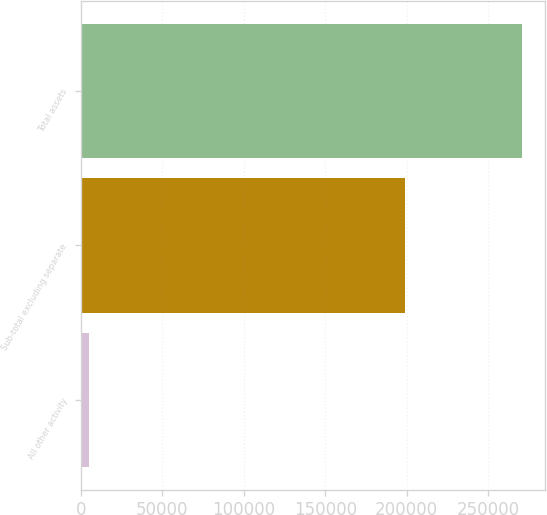<chart> <loc_0><loc_0><loc_500><loc_500><bar_chart><fcel>All other activity<fcel>Sub-total excluding separate<fcel>Total assets<nl><fcel>4731<fcel>198683<fcel>270975<nl></chart> 